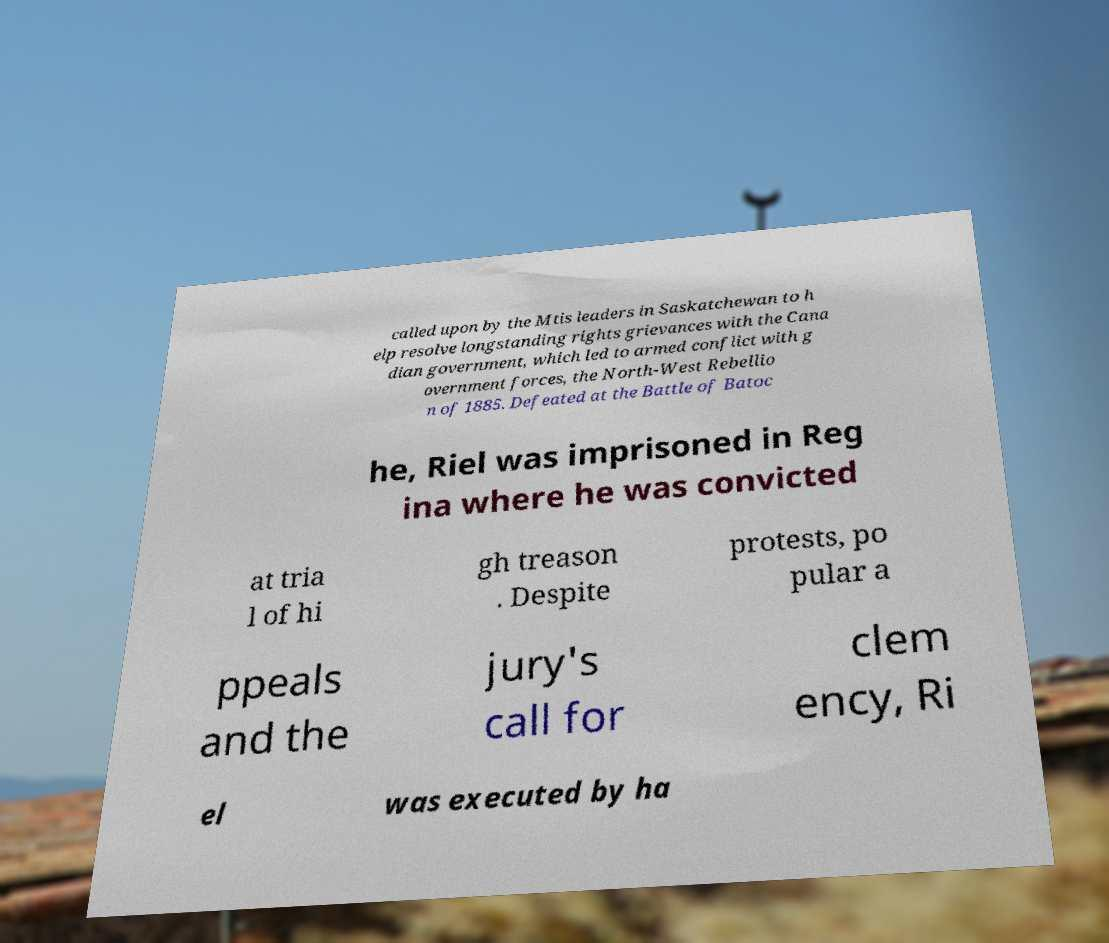What messages or text are displayed in this image? I need them in a readable, typed format. called upon by the Mtis leaders in Saskatchewan to h elp resolve longstanding rights grievances with the Cana dian government, which led to armed conflict with g overnment forces, the North-West Rebellio n of 1885. Defeated at the Battle of Batoc he, Riel was imprisoned in Reg ina where he was convicted at tria l of hi gh treason . Despite protests, po pular a ppeals and the jury's call for clem ency, Ri el was executed by ha 